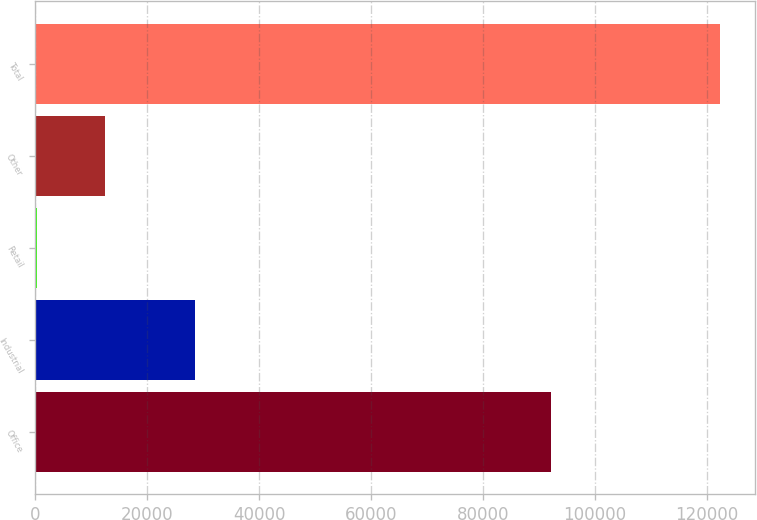Convert chart. <chart><loc_0><loc_0><loc_500><loc_500><bar_chart><fcel>Office<fcel>Industrial<fcel>Retail<fcel>Other<fcel>Total<nl><fcel>92190<fcel>28585<fcel>281<fcel>12497.9<fcel>122450<nl></chart> 